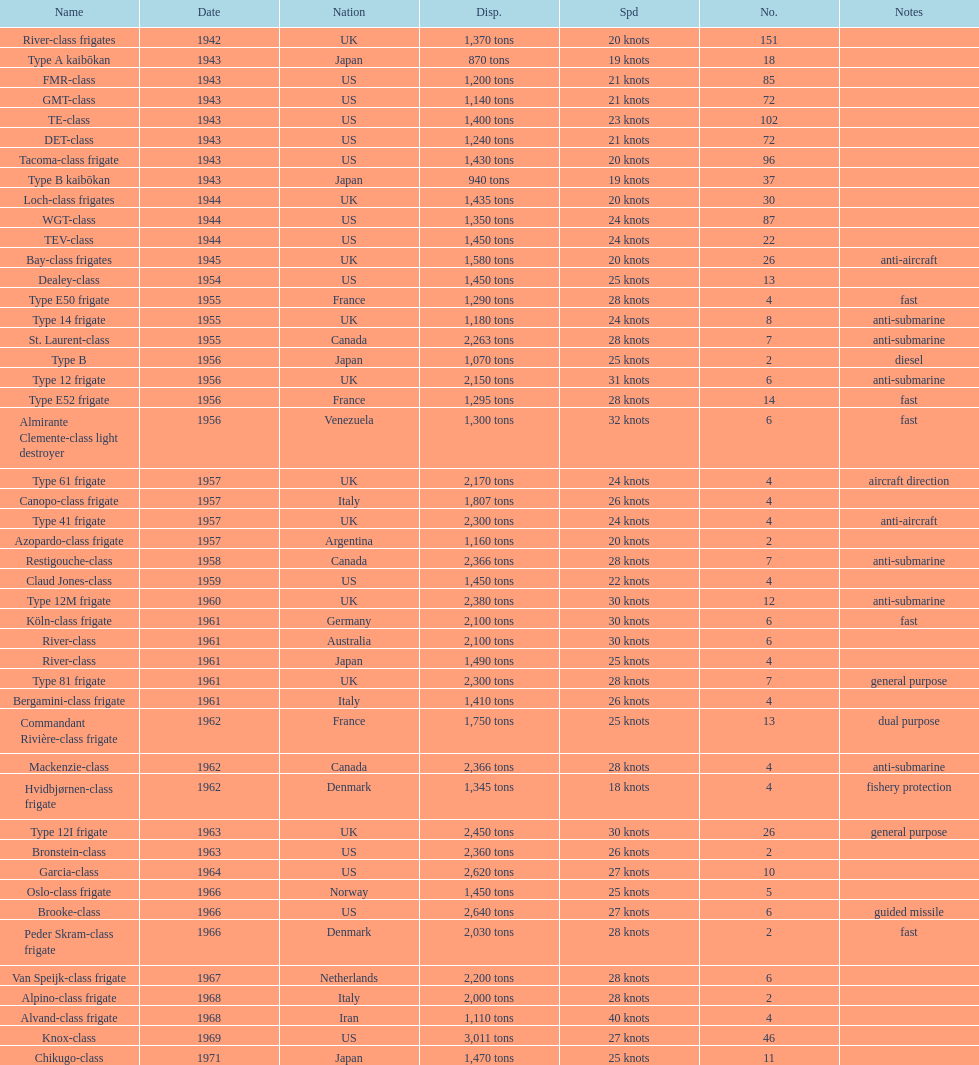Which name has the largest displacement? Knox-class. 